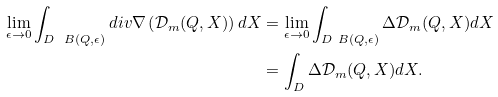<formula> <loc_0><loc_0><loc_500><loc_500>\lim _ { \epsilon \rightarrow 0 } \int _ { D \ B ( Q , \epsilon ) } d i v \nabla \left ( \mathcal { D } _ { m } ( Q , X ) \right ) d X & = \lim _ { \epsilon \rightarrow 0 } \int _ { D \ B ( Q , \epsilon ) } \Delta \mathcal { D } _ { m } ( Q , X ) d X \\ & = \int _ { D } \Delta \mathcal { D } _ { m } ( Q , X ) d X .</formula> 